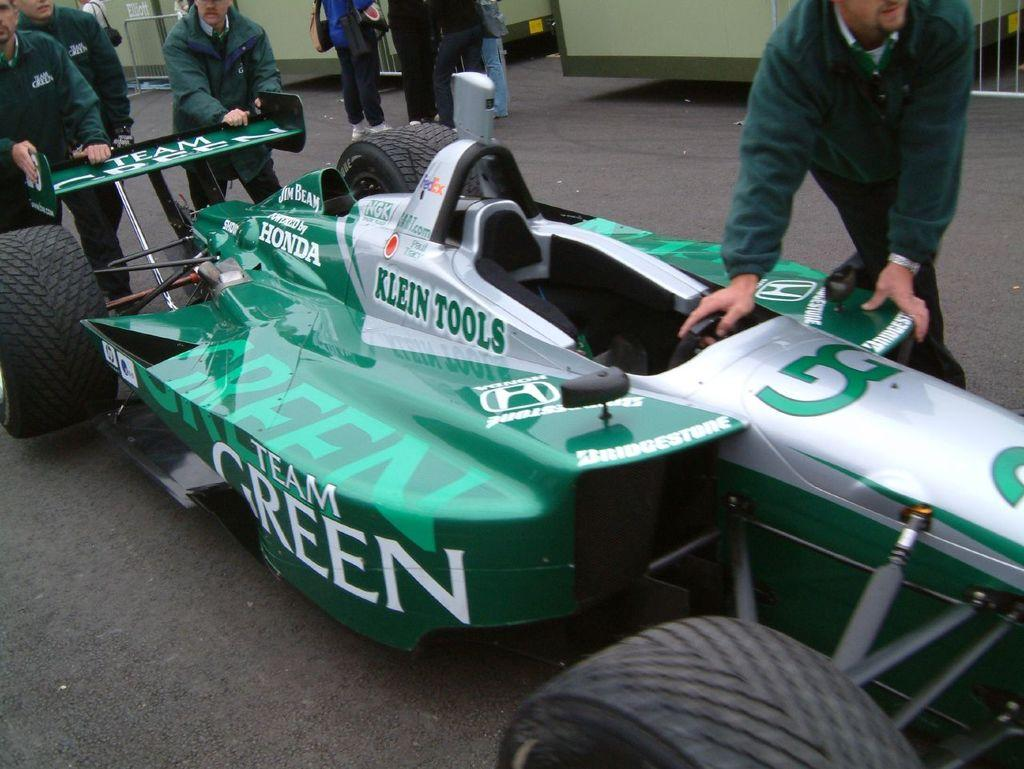What is the main subject of the image? There is a sports car in the center of the image. Are there any people present in the image? Yes, there are people around the sports car. What can be seen in the background of the image? There is a barricade and containers in the background. What type of plant is growing on the hood of the sports car in the image? There is no plant growing on the hood of the sports car in the image. How many nails can be seen in the image? There are no nails visible in the image. 